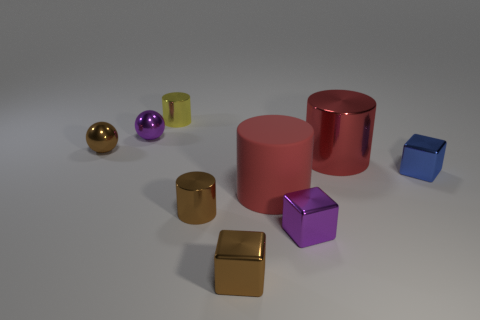Is there anything else that is the same size as the brown shiny ball?
Keep it short and to the point. Yes. What shape is the other thing that is the same color as the rubber thing?
Provide a short and direct response. Cylinder. Is the size of the brown metal cube the same as the blue cube?
Your answer should be compact. Yes. Are there any brown metallic cylinders?
Keep it short and to the point. Yes. The shiny object that is the same color as the matte cylinder is what size?
Your answer should be compact. Large. There is a brown thing on the left side of the tiny shiny thing that is behind the tiny purple thing behind the red matte object; what is its size?
Provide a short and direct response. Small. How many small things are made of the same material as the brown sphere?
Offer a very short reply. 6. How many blue shiny objects have the same size as the brown metal ball?
Provide a short and direct response. 1. There is a small purple object in front of the large rubber object in front of the tiny cylinder behind the red shiny cylinder; what is it made of?
Ensure brevity in your answer.  Metal. What number of objects are either tiny blocks or large metal objects?
Give a very brief answer. 4. 